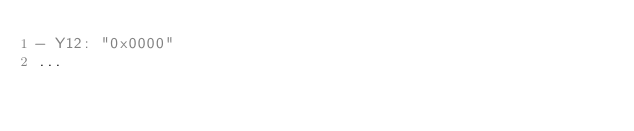<code> <loc_0><loc_0><loc_500><loc_500><_YAML_>- Y12: "0x0000"
...

</code> 